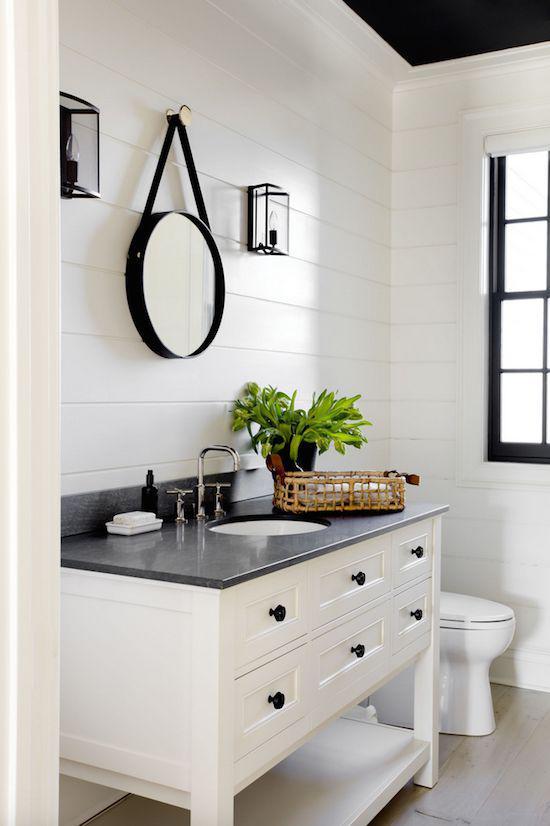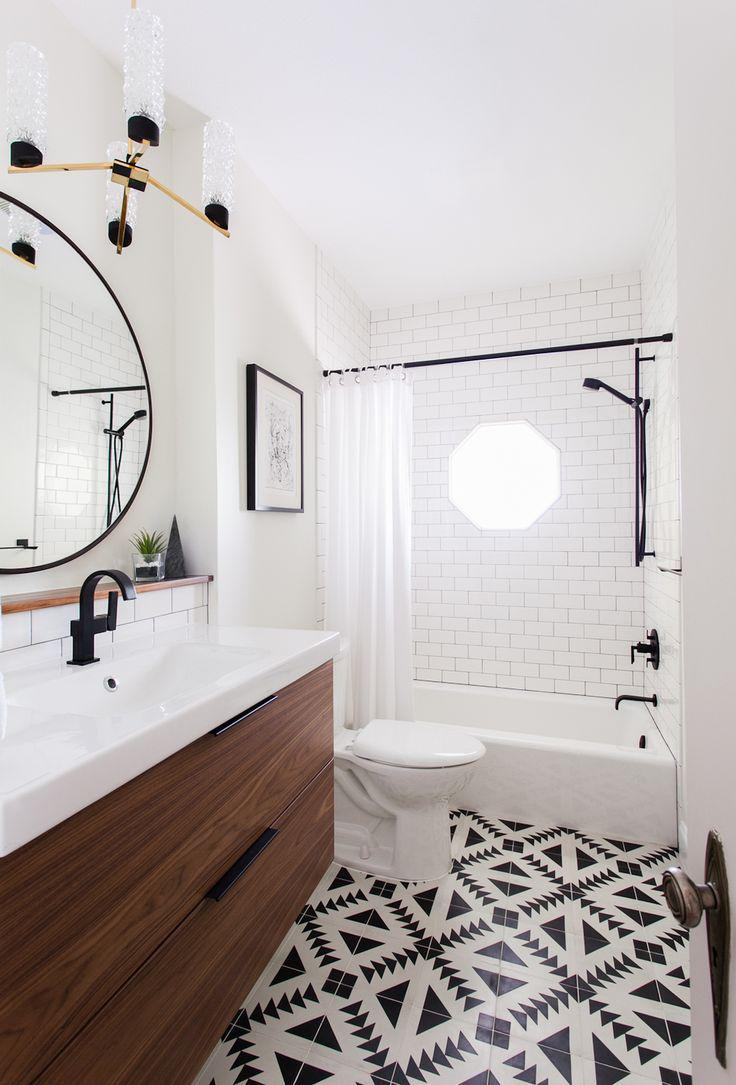The first image is the image on the left, the second image is the image on the right. Assess this claim about the two images: "In a bathroom with black and white patterned flooring, a wide wooden vanity is topped with one or more white sink fixtures that is backed with at least two rows of white tiles.". Correct or not? Answer yes or no. Yes. The first image is the image on the left, the second image is the image on the right. Assess this claim about the two images: "The bathroom on the right has a black-and-white diamond pattern floor and a long brown sink vanity.". Correct or not? Answer yes or no. Yes. 